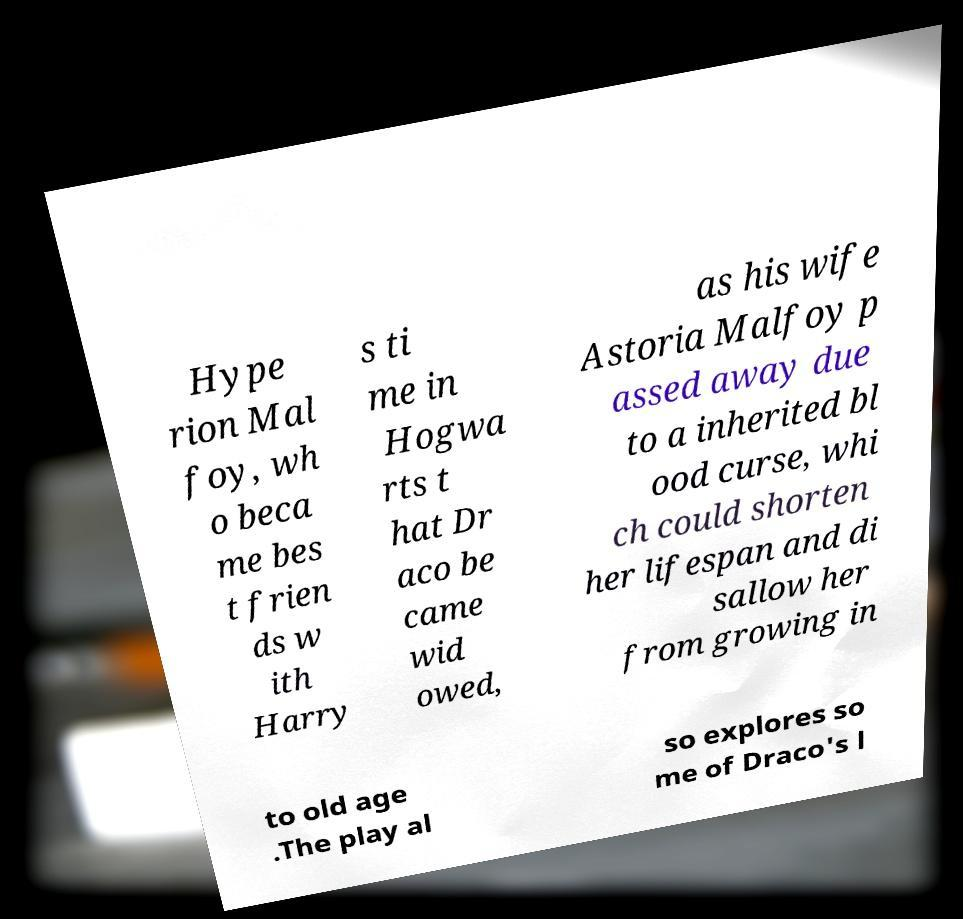Please identify and transcribe the text found in this image. Hype rion Mal foy, wh o beca me bes t frien ds w ith Harry s ti me in Hogwa rts t hat Dr aco be came wid owed, as his wife Astoria Malfoy p assed away due to a inherited bl ood curse, whi ch could shorten her lifespan and di sallow her from growing in to old age .The play al so explores so me of Draco's l 